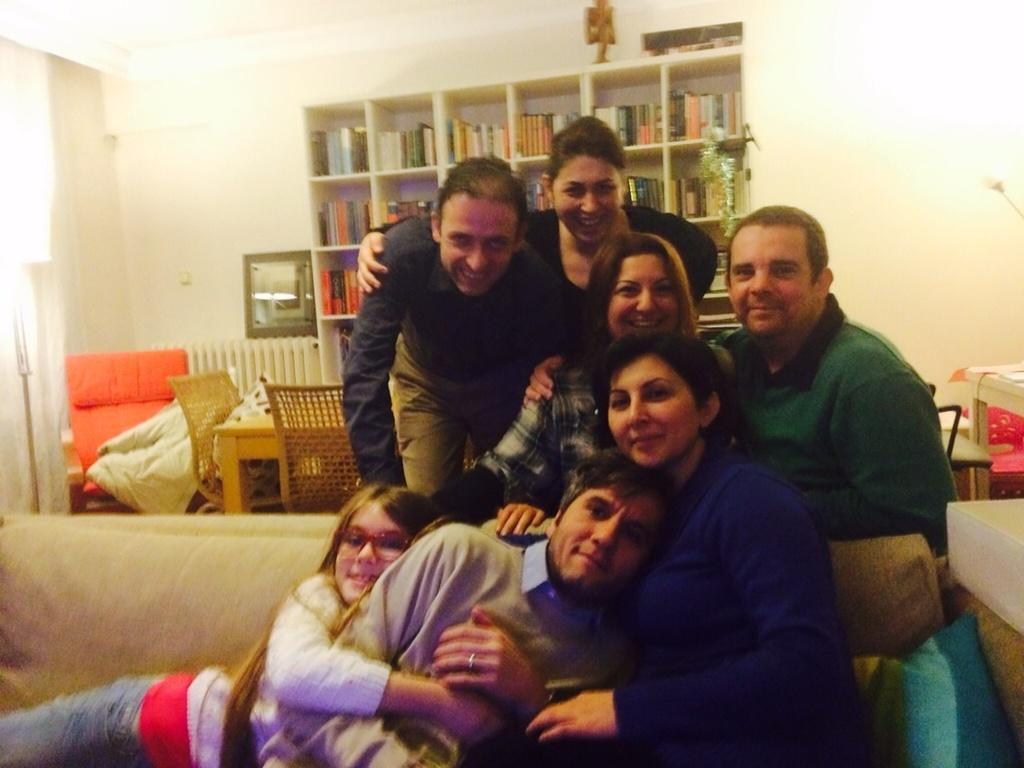Can you describe this image briefly? there are people. behind them there are bookshelves. 